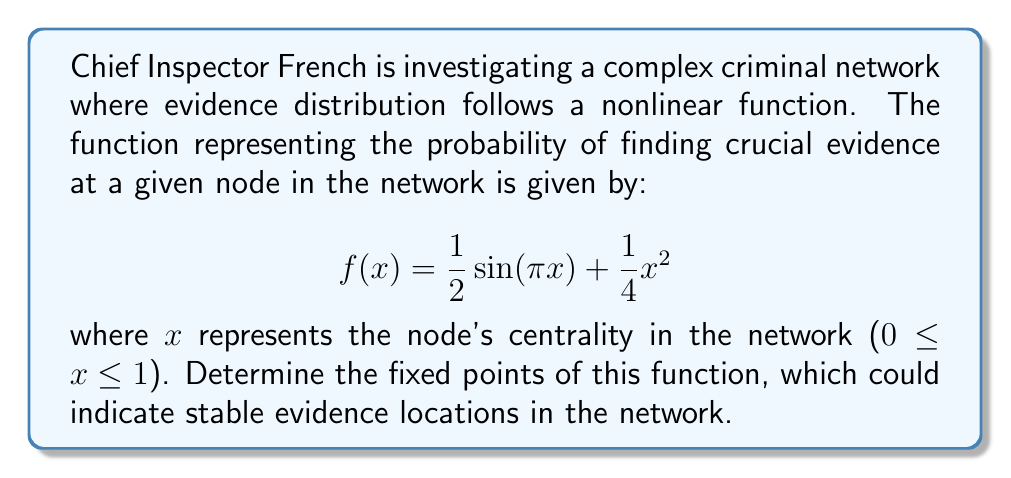Provide a solution to this math problem. To find the fixed points of the function, we need to solve the equation $f(x) = x$. This gives us:

$$\frac{1}{2}\sin(\pi x) + \frac{1}{4}x^2 = x$$

Let's approach this step-by-step, as Chief Inspector French would:

1) Rearrange the equation:
   $$\frac{1}{2}\sin(\pi x) + \frac{1}{4}x^2 - x = 0$$

2) Multiply all terms by 4 to eliminate fractions:
   $$2\sin(\pi x) + x^2 - 4x = 0$$

3) Let $g(x) = 2\sin(\pi x) + x^2 - 4x$. We need to find the roots of $g(x)$.

4) Observe that $g(0) = 0$, so $x = 0$ is one fixed point.

5) For other fixed points, we can use numerical methods like the Newton-Raphson method or graphical analysis.

6) Using a graphing calculator or computer software, we can see that $g(x)$ crosses the x-axis at two more points: one near $x ≈ 0.2$ and another near $x ≈ 0.8$.

7) Refining these values numerically, we get the approximate fixed points:
   $x ≈ 0.2087$ and $x ≈ 0.7913$

Therefore, the function has three fixed points: 0 and two others approximately at 0.2087 and 0.7913.
Answer: $x = 0$, $x ≈ 0.2087$, and $x ≈ 0.7913$ 